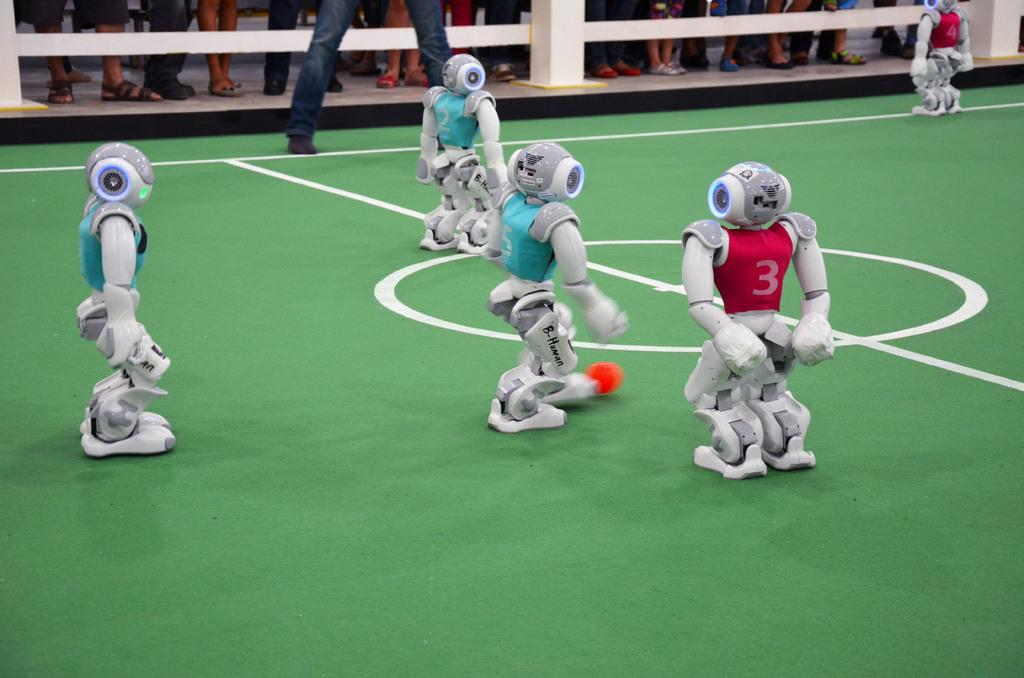What type of objects are present on the green surface in the image? There are robots on a green surface in the image. What other visual elements can be seen in the image? There are white lines and an orange color object visible in the image. What part of a person can be seen at the top of the image? Human legs are visible at the top of the image. What structure is present at the top of the image? There is a railing at the top of the image. What type of magic is being performed by the robots in the image? There is no magic being performed by the robots in the image; they are simply present on the green surface. Can you see a ball being used by the robots in the image? There is no ball present in the image. 